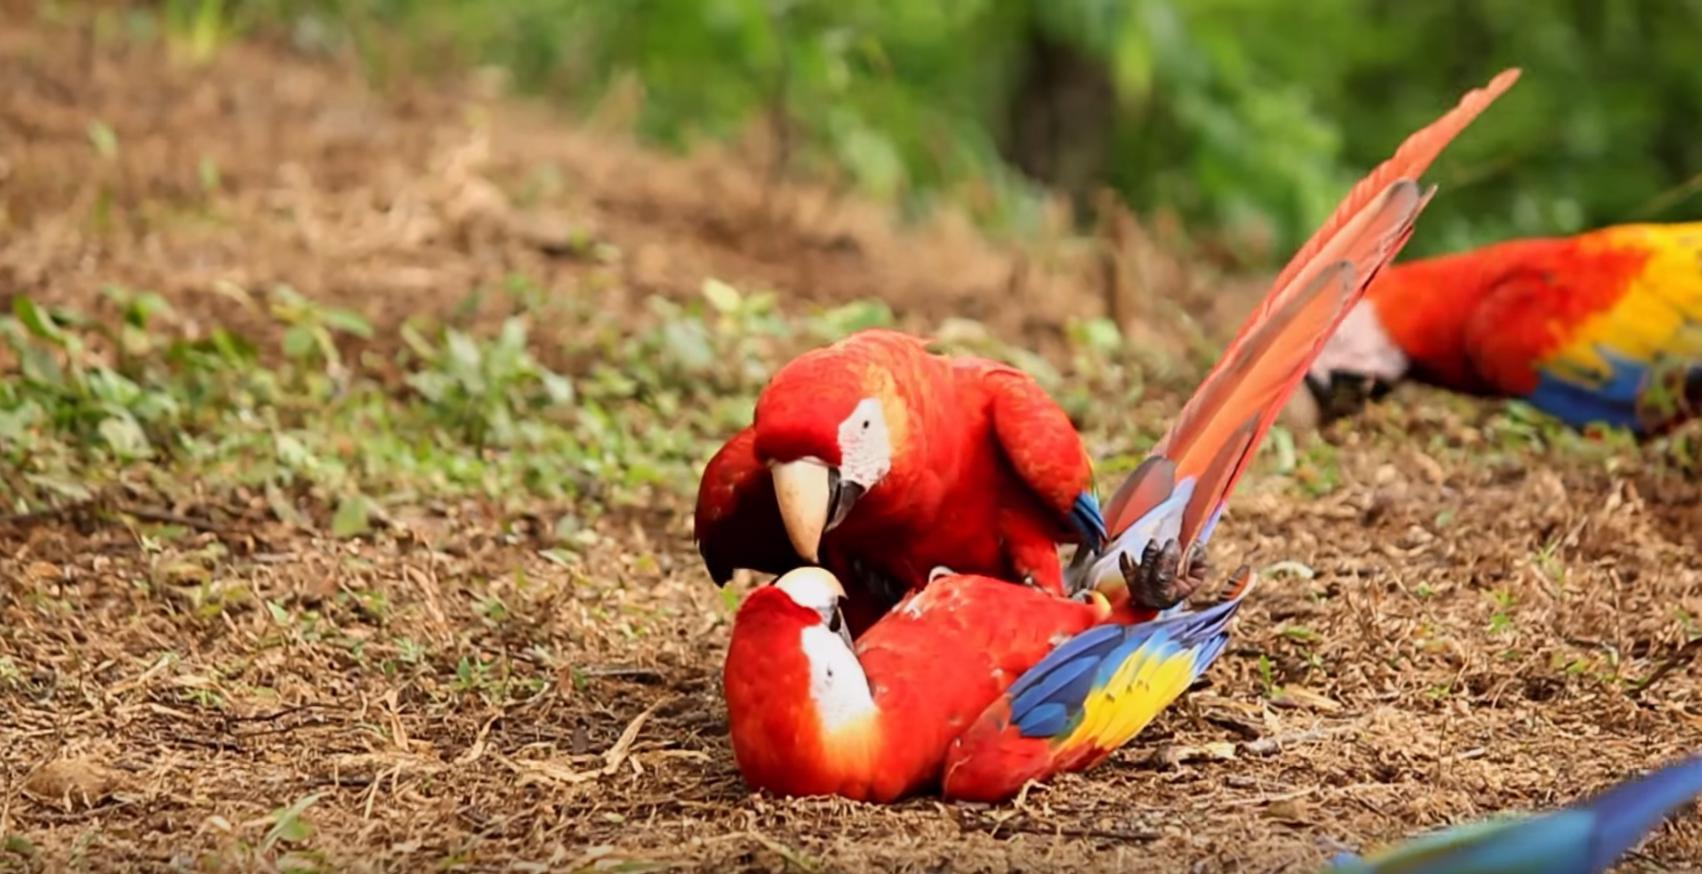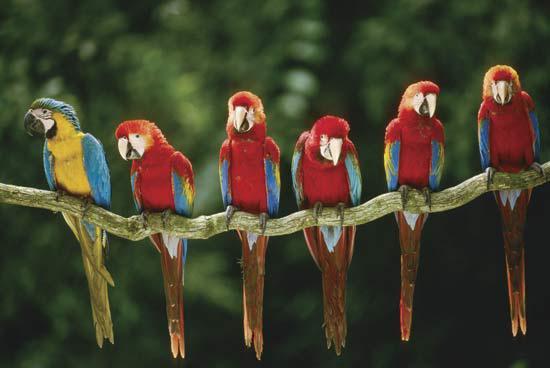The first image is the image on the left, the second image is the image on the right. Given the left and right images, does the statement "There are less than four birds." hold true? Answer yes or no. No. The first image is the image on the left, the second image is the image on the right. Examine the images to the left and right. Is the description "There are no more than three birds" accurate? Answer yes or no. No. The first image is the image on the left, the second image is the image on the right. For the images displayed, is the sentence "More than four parrots are standing on the same stick and facing the same direction." factually correct? Answer yes or no. Yes. 